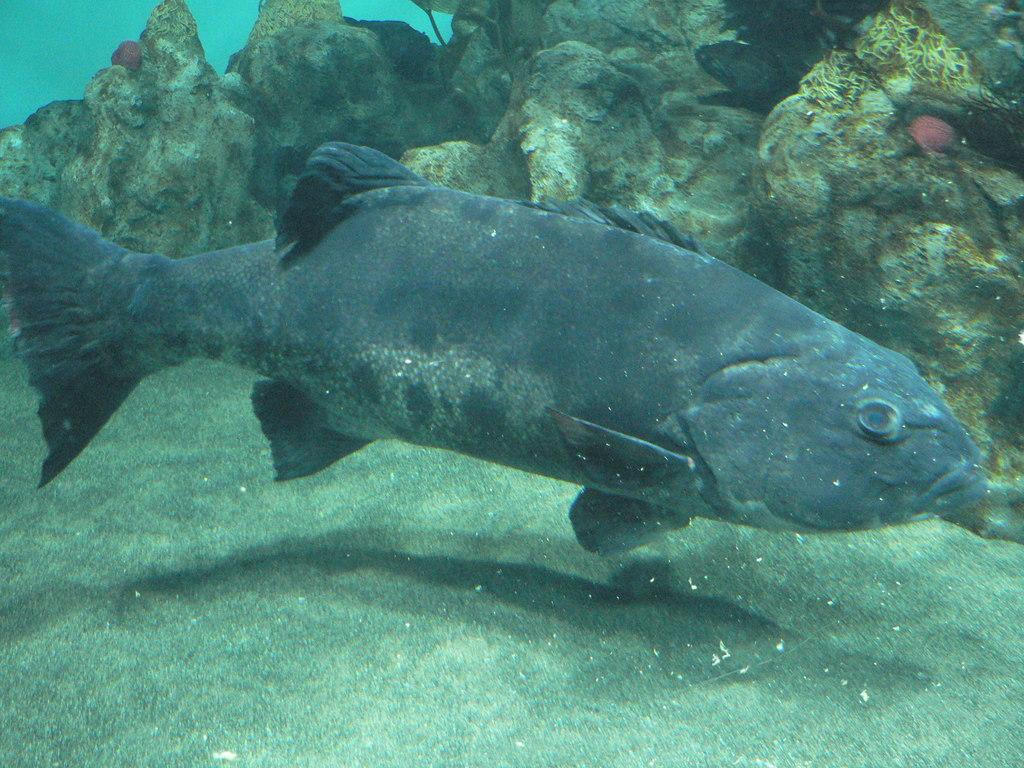What type of animal can be seen in the water in the image? There is a fish in the water in the image. What can be seen in the background of the image? There are rocks visible in the background of the image. Where can the cherries be found in the image? There are no cherries present in the image. What type of design is featured on the fish in the image? The image does not show any specific design on the fish; it only depicts a fish in the water. 